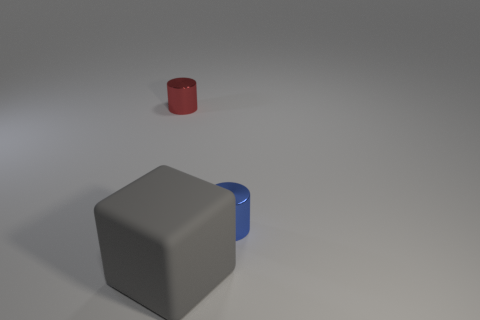Add 1 blue rubber cylinders. How many objects exist? 4 Add 3 big matte blocks. How many big matte blocks are left? 4 Add 2 small red objects. How many small red objects exist? 3 Subtract 0 purple balls. How many objects are left? 3 Subtract all cubes. How many objects are left? 2 Subtract all blue things. Subtract all brown cubes. How many objects are left? 2 